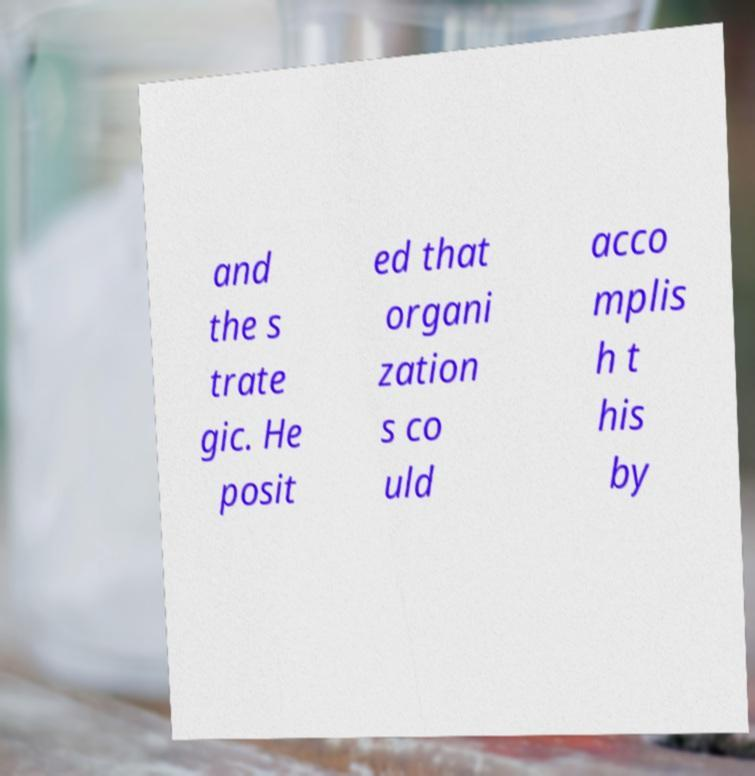Could you extract and type out the text from this image? and the s trate gic. He posit ed that organi zation s co uld acco mplis h t his by 